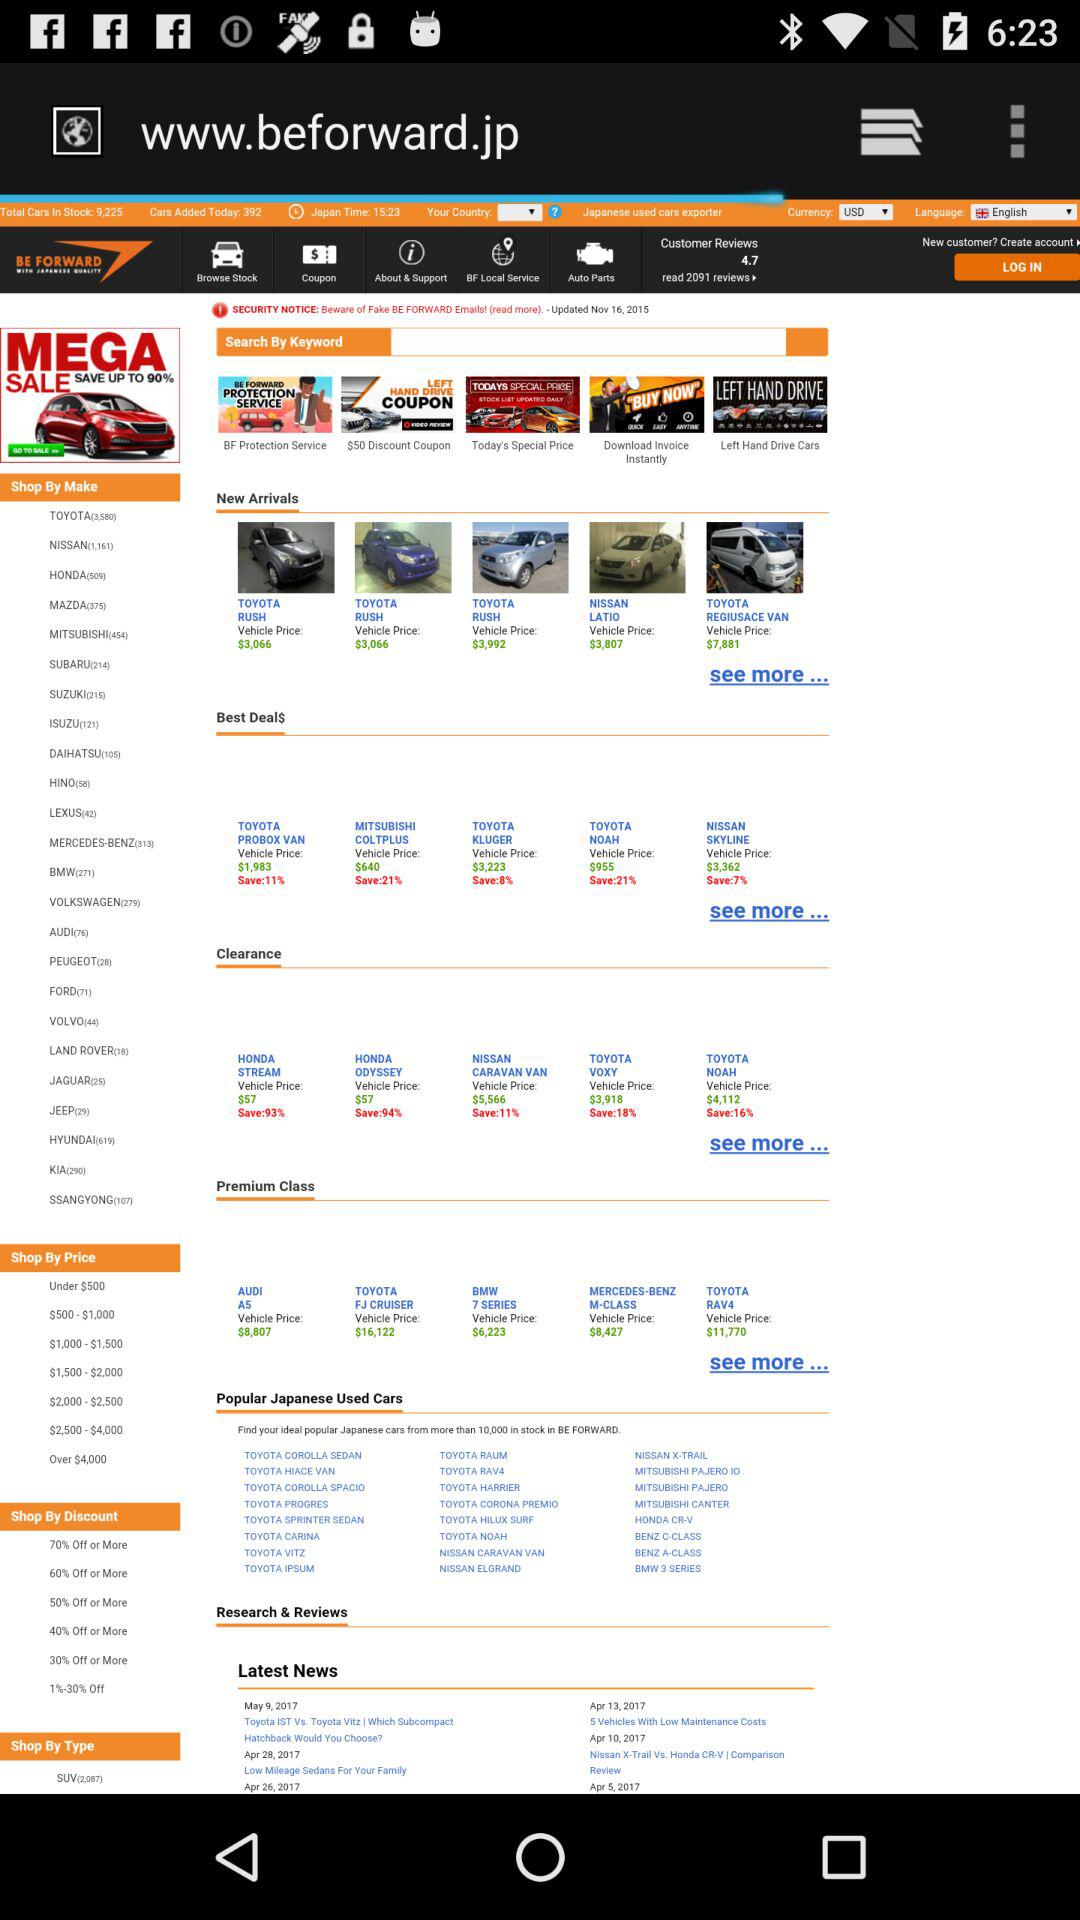What is the price of "HONDA STREAM"? The price of "HONDA STREAM" is $57. 